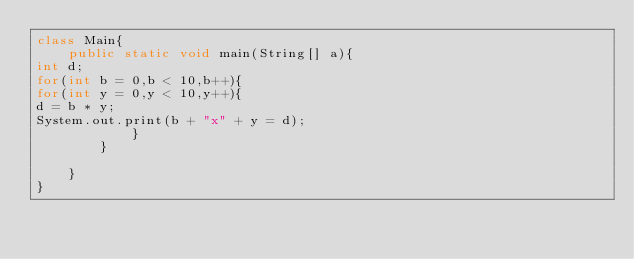Convert code to text. <code><loc_0><loc_0><loc_500><loc_500><_Java_>class Main{
    public static void main(String[] a){
int d;
for(int b = 0,b < 10,b++){
for(int y = 0,y < 10,y++){
d = b * y;
System.out.print(b + "x" + y = d);
            }
        }

    }
}</code> 